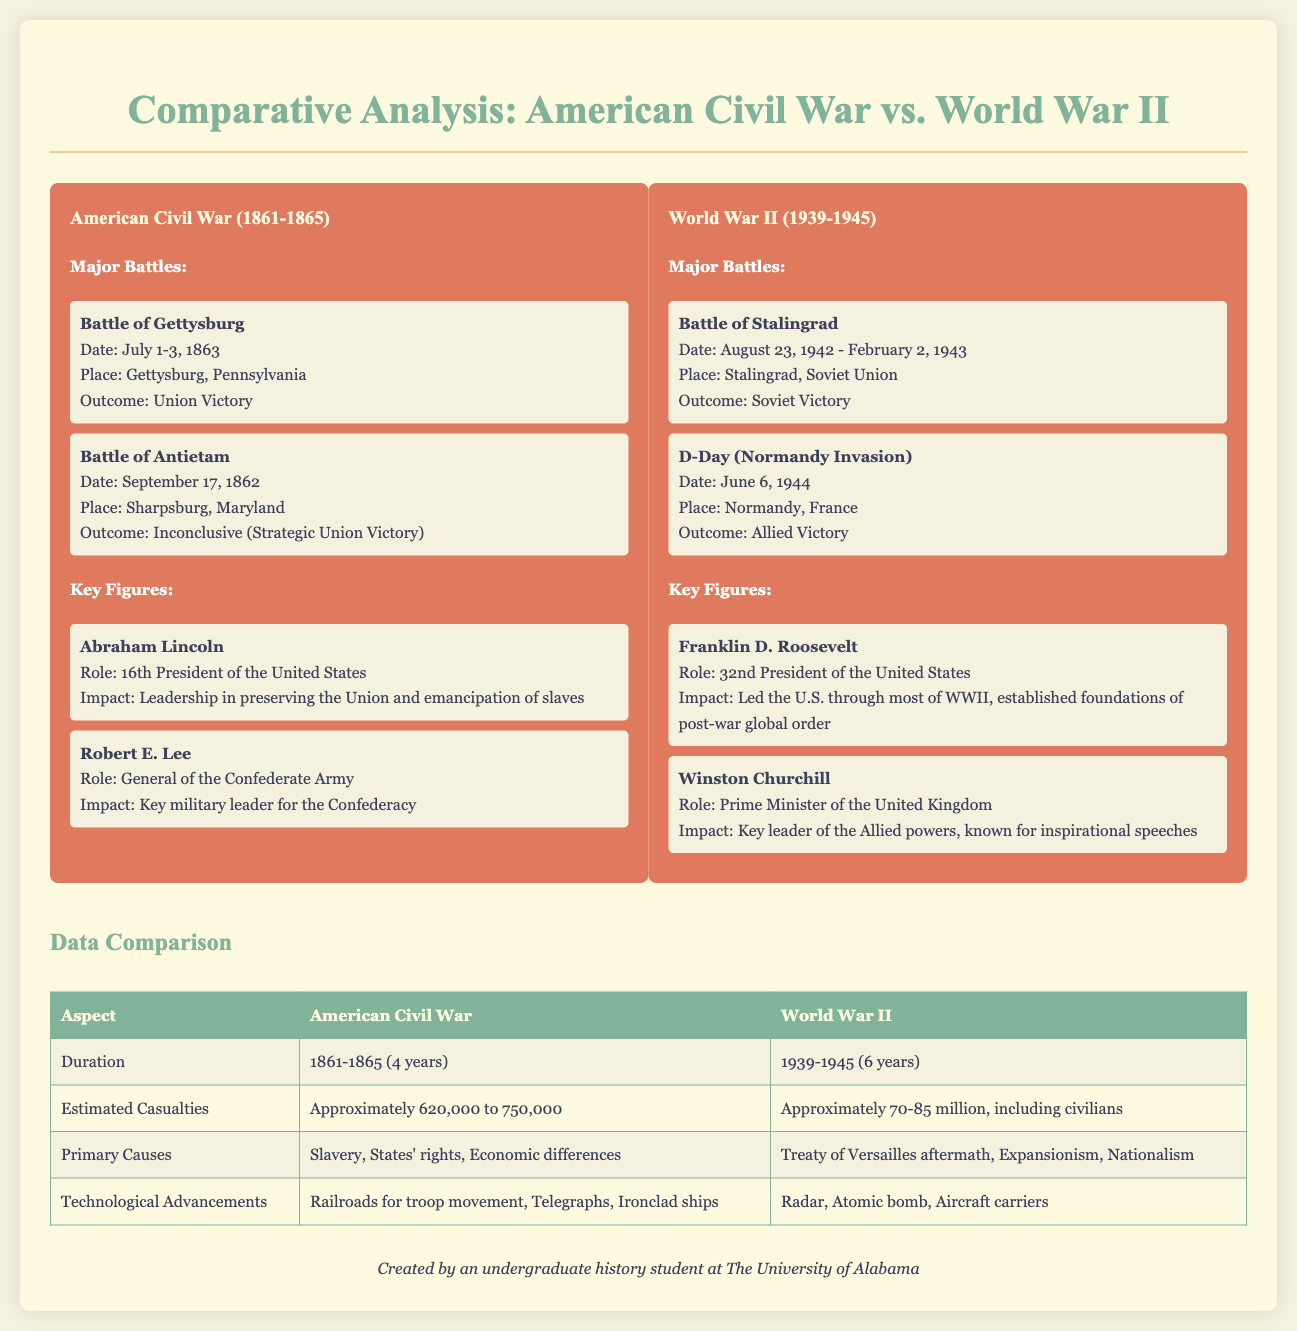What year did the American Civil War start? The document provides the timeline for the American Civil War as being from 1861 to 1865, indicating it started in 1861.
Answer: 1861 What was the outcome of the Battle of Gettysburg? The document states that the outcome of the Battle of Gettysburg was a Union Victory.
Answer: Union Victory Who was the Prime Minister of the United Kingdom during World War II? The document identifies Winston Churchill as the Prime Minister of the United Kingdom during World War II.
Answer: Winston Churchill What were the primary causes of the American Civil War? According to the data comparison in the document, the primary causes were slavery, states' rights, and economic differences.
Answer: Slavery, States' rights, Economic differences Which battle is noted for being an inconclusive outcome in the American Civil War? The document notes the Battle of Antietam as having an inconclusive outcome while being considered a strategic Union Victory.
Answer: Battle of Antietam What was the duration of World War II? The document states that World War II lasted from 1939 to 1945, making its duration six years.
Answer: 6 years Who was the 16th President of the United States? The document mentions Abraham Lincoln as the 16th President of the United States.
Answer: Abraham Lincoln What technological advancement was prominent during the American Civil War? The document lists railroads for troop movement as one of the key technological advancements during the American Civil War.
Answer: Railroads for troop movement What is the estimated number of casualties in World War II? According to the data comparison, the document estimates the casualties of World War II to be approximately 70 to 85 million including civilians.
Answer: Approximately 70-85 million 